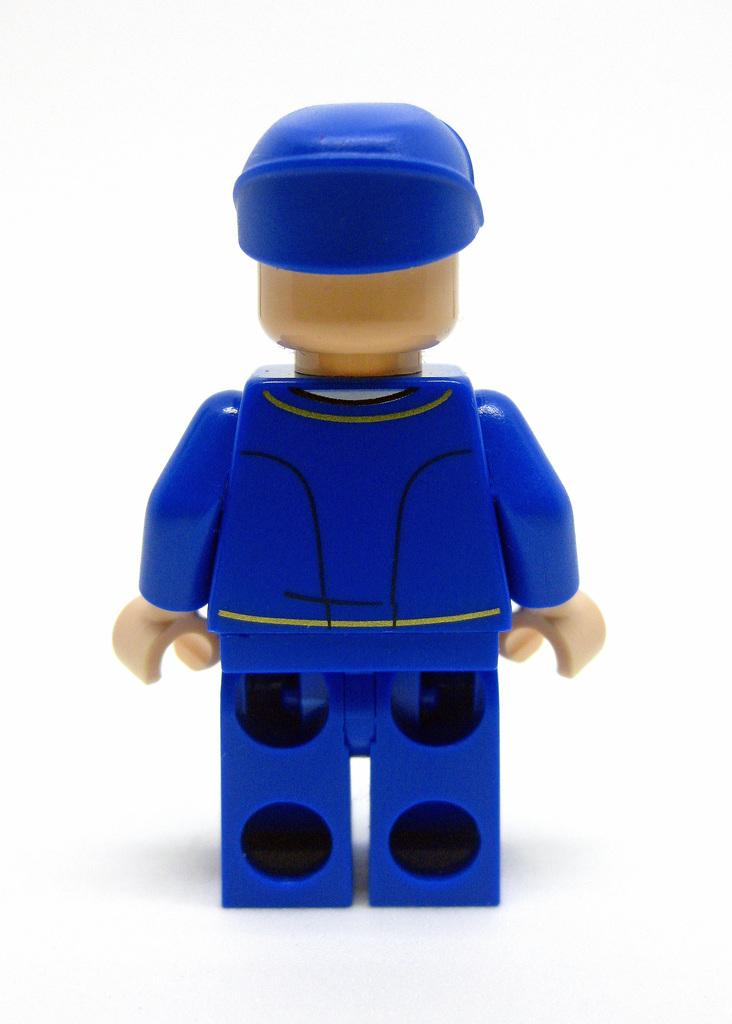What is the main object in the image? There is a blue color toy in the image. What are the color details of the toy? The toy has a cream color head and hands. What is the color of the background in the image? The background of the image is white. Can you tell me how many girls are holding the toy in the image? There are no girls present in the image; it only features the blue color toy. What type of snail can be seen crawling on the toy in the image? There is no snail present on the toy in the image. 